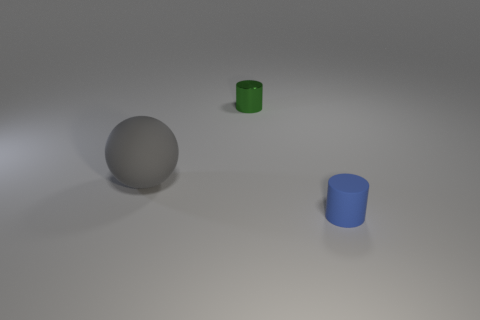Are there fewer objects to the left of the metal cylinder than tiny matte cylinders that are left of the gray matte ball?
Ensure brevity in your answer.  No. Is there another big rubber sphere of the same color as the rubber ball?
Give a very brief answer. No. Are the tiny blue cylinder and the small cylinder behind the gray sphere made of the same material?
Provide a succinct answer. No. There is a rubber thing that is right of the metal thing; is there a big sphere that is in front of it?
Keep it short and to the point. No. There is a object that is in front of the tiny metal cylinder and right of the big rubber sphere; what is its color?
Your answer should be very brief. Blue. The gray matte thing has what size?
Provide a succinct answer. Large. How many blue rubber cylinders have the same size as the shiny object?
Provide a short and direct response. 1. Is the tiny cylinder in front of the sphere made of the same material as the object that is to the left of the tiny green object?
Your answer should be compact. Yes. What material is the small object that is in front of the rubber object left of the tiny green shiny cylinder?
Offer a terse response. Rubber. What is the large thing behind the small rubber cylinder made of?
Give a very brief answer. Rubber. 